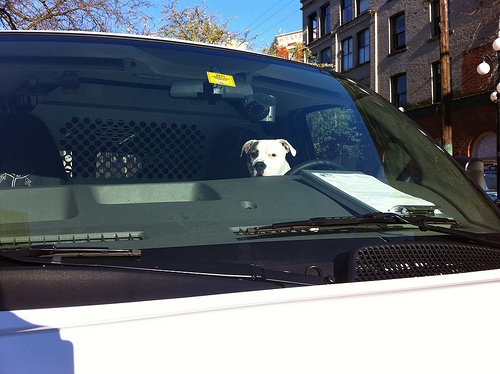<image>
Can you confirm if the dog is behind the car? No. The dog is not behind the car. From this viewpoint, the dog appears to be positioned elsewhere in the scene. 